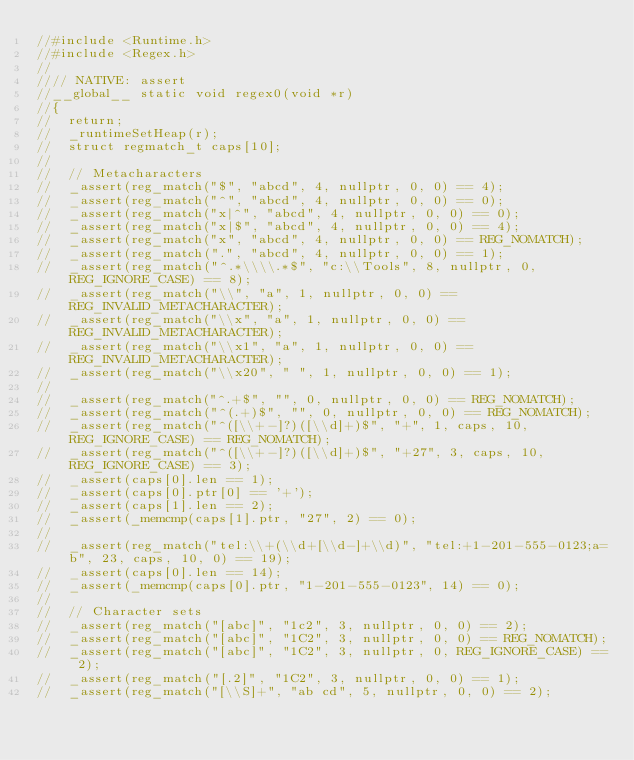Convert code to text. <code><loc_0><loc_0><loc_500><loc_500><_Cuda_>//#include <Runtime.h>
//#include <Regex.h>
//
//// NATIVE: assert
//__global__ static void regex0(void *r)
//{
//	return;
//	_runtimeSetHeap(r);
//	struct regmatch_t caps[10];
//
//	// Metacharacters
//	_assert(reg_match("$", "abcd", 4, nullptr, 0, 0) == 4);
//	_assert(reg_match("^", "abcd", 4, nullptr, 0, 0) == 0);
//	_assert(reg_match("x|^", "abcd", 4, nullptr, 0, 0) == 0);
//	_assert(reg_match("x|$", "abcd", 4, nullptr, 0, 0) == 4);
//	_assert(reg_match("x", "abcd", 4, nullptr, 0, 0) == REG_NOMATCH);
//	_assert(reg_match(".", "abcd", 4, nullptr, 0, 0) == 1);
//	_assert(reg_match("^.*\\\\.*$", "c:\\Tools", 8, nullptr, 0, REG_IGNORE_CASE) == 8);
//	_assert(reg_match("\\", "a", 1, nullptr, 0, 0) == REG_INVALID_METACHARACTER);
//	_assert(reg_match("\\x", "a", 1, nullptr, 0, 0) == REG_INVALID_METACHARACTER);
//	_assert(reg_match("\\x1", "a", 1, nullptr, 0, 0) == REG_INVALID_METACHARACTER);
//	_assert(reg_match("\\x20", " ", 1, nullptr, 0, 0) == 1);
//
//	_assert(reg_match("^.+$", "", 0, nullptr, 0, 0) == REG_NOMATCH);
//	_assert(reg_match("^(.+)$", "", 0, nullptr, 0, 0) == REG_NOMATCH);
//	_assert(reg_match("^([\\+-]?)([\\d]+)$", "+", 1, caps, 10, REG_IGNORE_CASE) == REG_NOMATCH);
//	_assert(reg_match("^([\\+-]?)([\\d]+)$", "+27", 3, caps, 10, REG_IGNORE_CASE) == 3);
//	_assert(caps[0].len == 1);
//	_assert(caps[0].ptr[0] == '+');
//	_assert(caps[1].len == 2);
//	_assert(_memcmp(caps[1].ptr, "27", 2) == 0);
//
//	_assert(reg_match("tel:\\+(\\d+[\\d-]+\\d)", "tel:+1-201-555-0123;a=b", 23, caps, 10, 0) == 19);
//	_assert(caps[0].len == 14);
//	_assert(_memcmp(caps[0].ptr, "1-201-555-0123", 14) == 0);
//
//	// Character sets
//	_assert(reg_match("[abc]", "1c2", 3, nullptr, 0, 0) == 2);
//	_assert(reg_match("[abc]", "1C2", 3, nullptr, 0, 0) == REG_NOMATCH);
//	_assert(reg_match("[abc]", "1C2", 3, nullptr, 0, REG_IGNORE_CASE) == 2);
//	_assert(reg_match("[.2]", "1C2", 3, nullptr, 0, 0) == 1);
//	_assert(reg_match("[\\S]+", "ab cd", 5, nullptr, 0, 0) == 2);</code> 